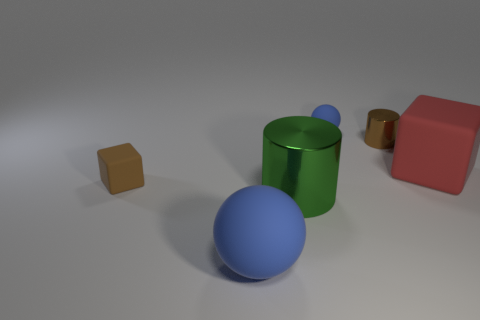Add 4 blue balls. How many objects exist? 10 Subtract all spheres. How many objects are left? 4 Subtract 0 cyan cubes. How many objects are left? 6 Subtract all large rubber balls. Subtract all small brown rubber objects. How many objects are left? 4 Add 4 metallic cylinders. How many metallic cylinders are left? 6 Add 1 big gray metallic cylinders. How many big gray metallic cylinders exist? 1 